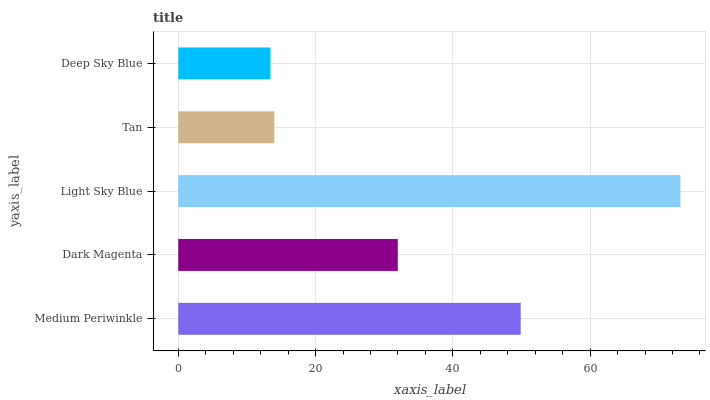Is Deep Sky Blue the minimum?
Answer yes or no. Yes. Is Light Sky Blue the maximum?
Answer yes or no. Yes. Is Dark Magenta the minimum?
Answer yes or no. No. Is Dark Magenta the maximum?
Answer yes or no. No. Is Medium Periwinkle greater than Dark Magenta?
Answer yes or no. Yes. Is Dark Magenta less than Medium Periwinkle?
Answer yes or no. Yes. Is Dark Magenta greater than Medium Periwinkle?
Answer yes or no. No. Is Medium Periwinkle less than Dark Magenta?
Answer yes or no. No. Is Dark Magenta the high median?
Answer yes or no. Yes. Is Dark Magenta the low median?
Answer yes or no. Yes. Is Tan the high median?
Answer yes or no. No. Is Deep Sky Blue the low median?
Answer yes or no. No. 